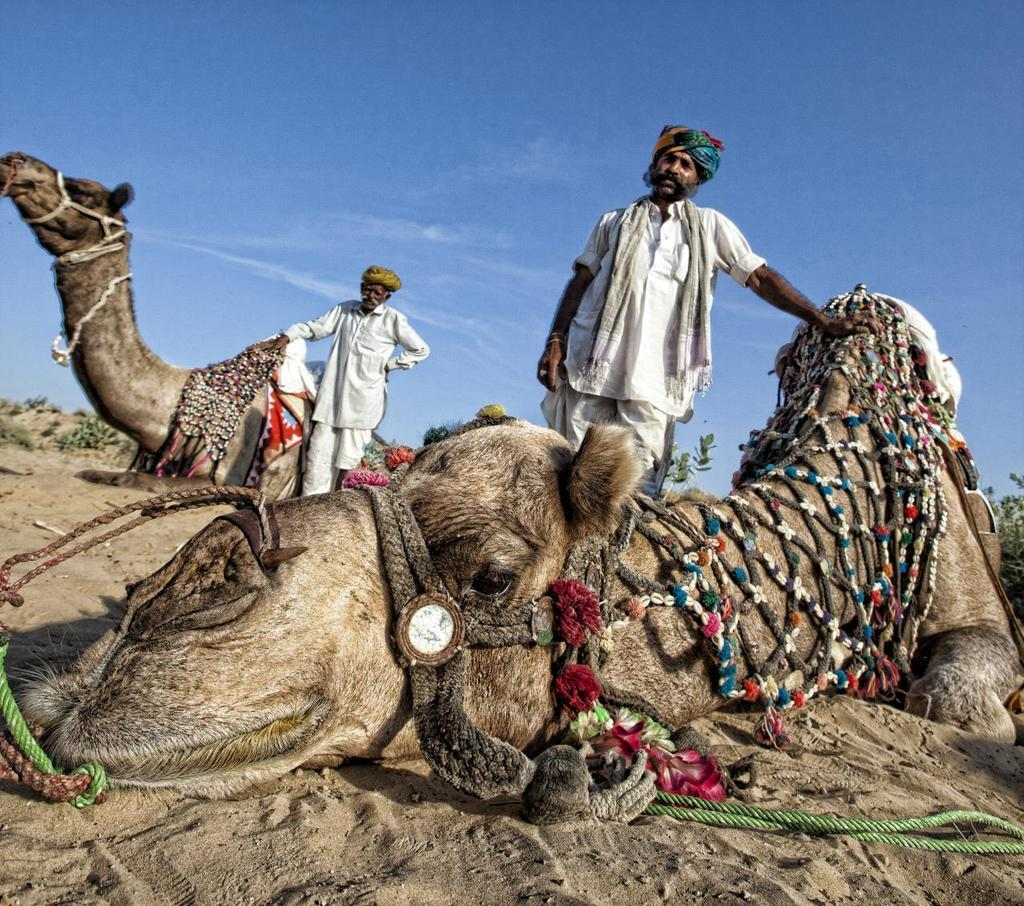What animals are lying down in the image? There are two camels lying in the image. What are the people in the image doing? The two people are standing on a path in the image. What can be seen in the background of the image? There are plants and the sky visible in the background of the image. What type of fruit is being used as a stamp by the camels in the image? There is no fruit or stamp present in the image; the camels are simply lying down. How deep is the quicksand that the people are trying to avoid in the image? There is no quicksand present in the image; the people are standing on a path. 